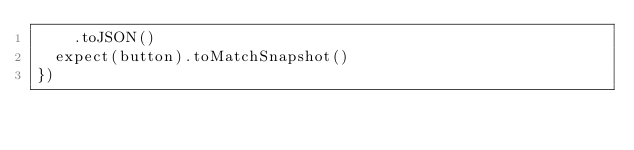Convert code to text. <code><loc_0><loc_0><loc_500><loc_500><_TypeScript_>    .toJSON()
  expect(button).toMatchSnapshot()
})
</code> 